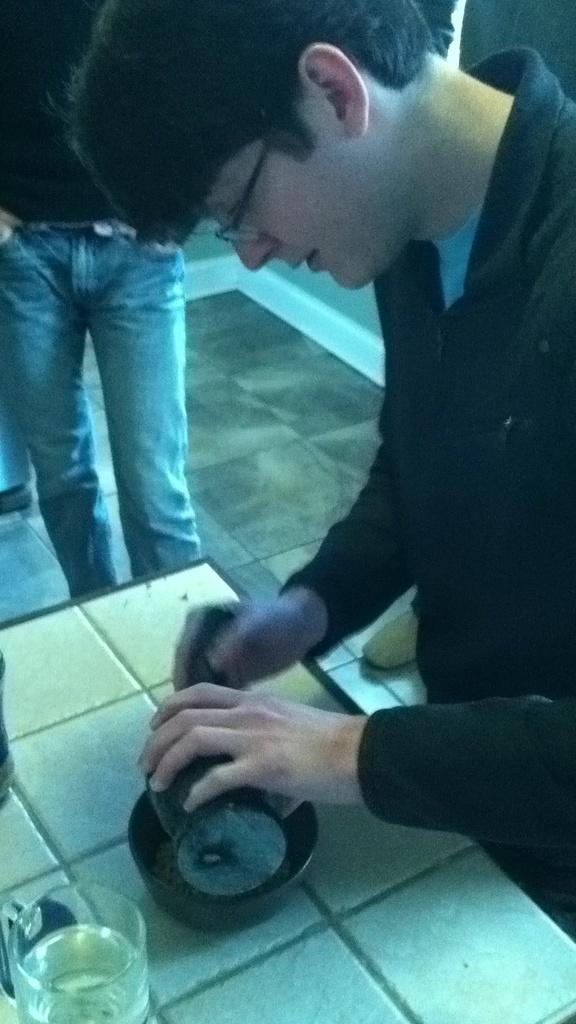How many people are in the image? There are two persons in the image. What is one of the persons doing with an object? One of the persons is holding an object. What type of container is present in the image? There is a bowl in the image. What type of beverage container is present in the image? There is a glass of drink in the image. What type of background can be seen in the image? There is a wall visible in the image. What type of knee injury can be seen on the monkey in the image? There is no monkey present in the image, and therefore no knee injury can be observed. What type of scene is depicted in the image? The image does not depict a specific scene; it simply shows two persons, a bowl, a glass of drink, and a wall. 